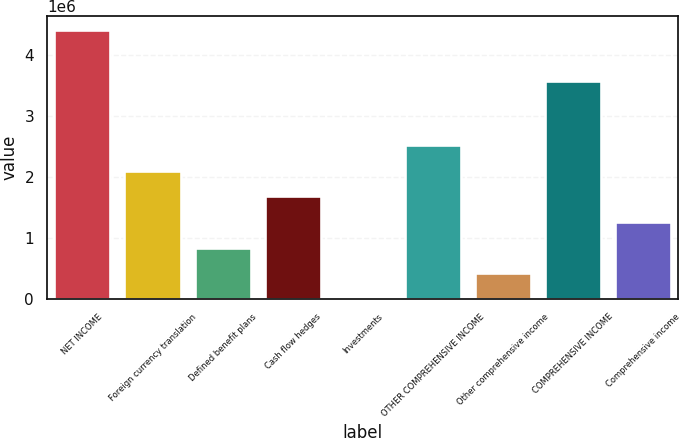Convert chart. <chart><loc_0><loc_0><loc_500><loc_500><bar_chart><fcel>NET INCOME<fcel>Foreign currency translation<fcel>Defined benefit plans<fcel>Cash flow hedges<fcel>Investments<fcel>OTHER COMPREHENSIVE INCOME<fcel>Other comprehensive income<fcel>COMPREHENSIVE INCOME<fcel>Comprehensive income<nl><fcel>4.42121e+06<fcel>2.10787e+06<fcel>843837<fcel>1.68653e+06<fcel>1148<fcel>2.52922e+06<fcel>422493<fcel>3.57852e+06<fcel>1.26518e+06<nl></chart> 